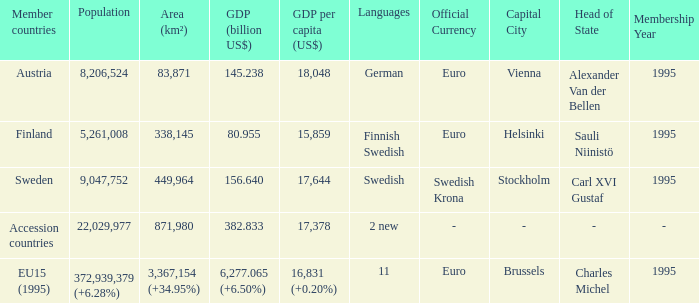Name the area for german 83871.0. 